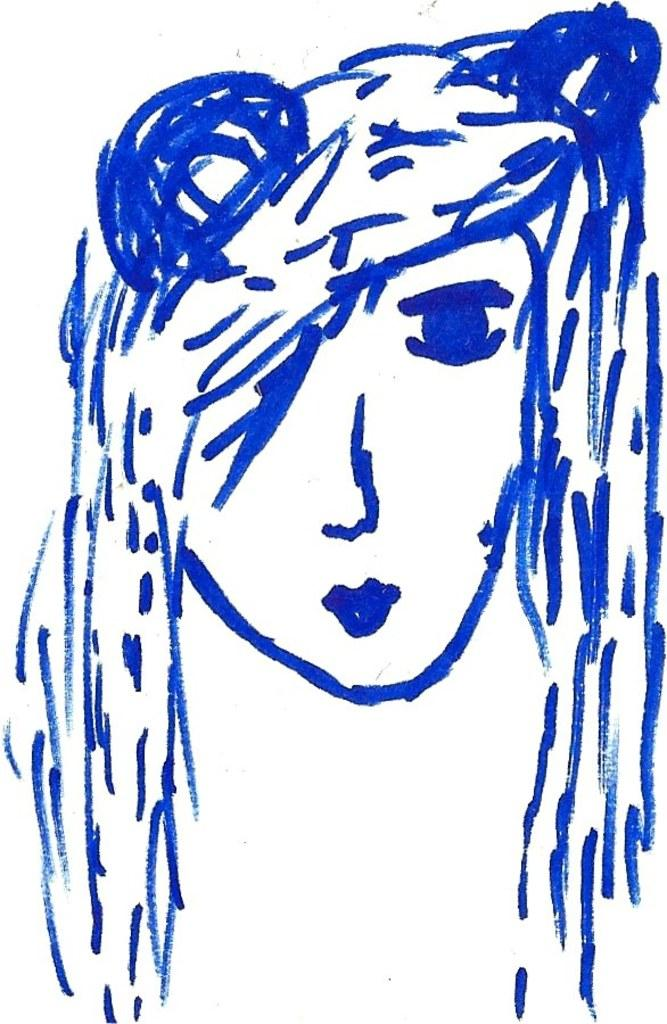What is the main subject of the drawing in the image? The main subject of the drawing in the image is a person's head. What color is used for the drawing? The drawing is in blue color. What type of suit is the person wearing in the drawing? There is no suit visible in the drawing, as it only depicts a person's head. 